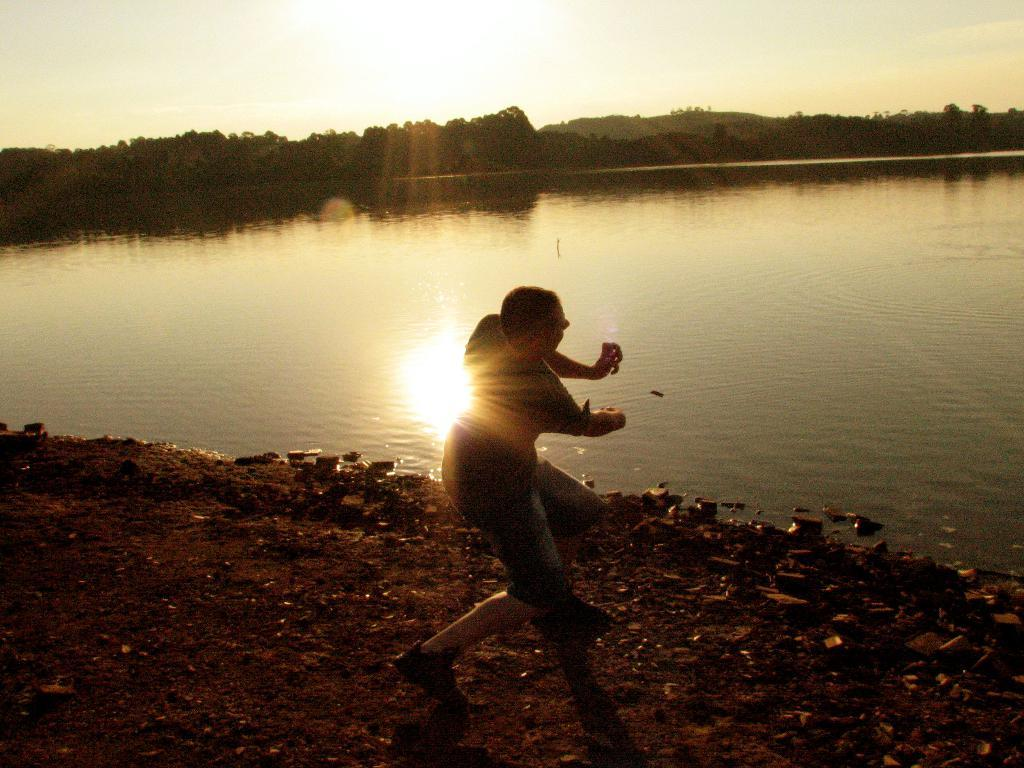What is the main feature in the middle of the image? There is a lake in the middle of the image. Can you describe the person in the image? There is a person in front of the lake in the foreground. What can be seen in the sky in the image? Sunlight and the sky are visible in the image. What type of vegetation is present in the image? Trees are present in the image. What type of shoes is the spy wearing while lying on the bed in the image? There is no spy or bed present in the image; it features a person in front of a lake with trees, sunlight, and the sky visible. 